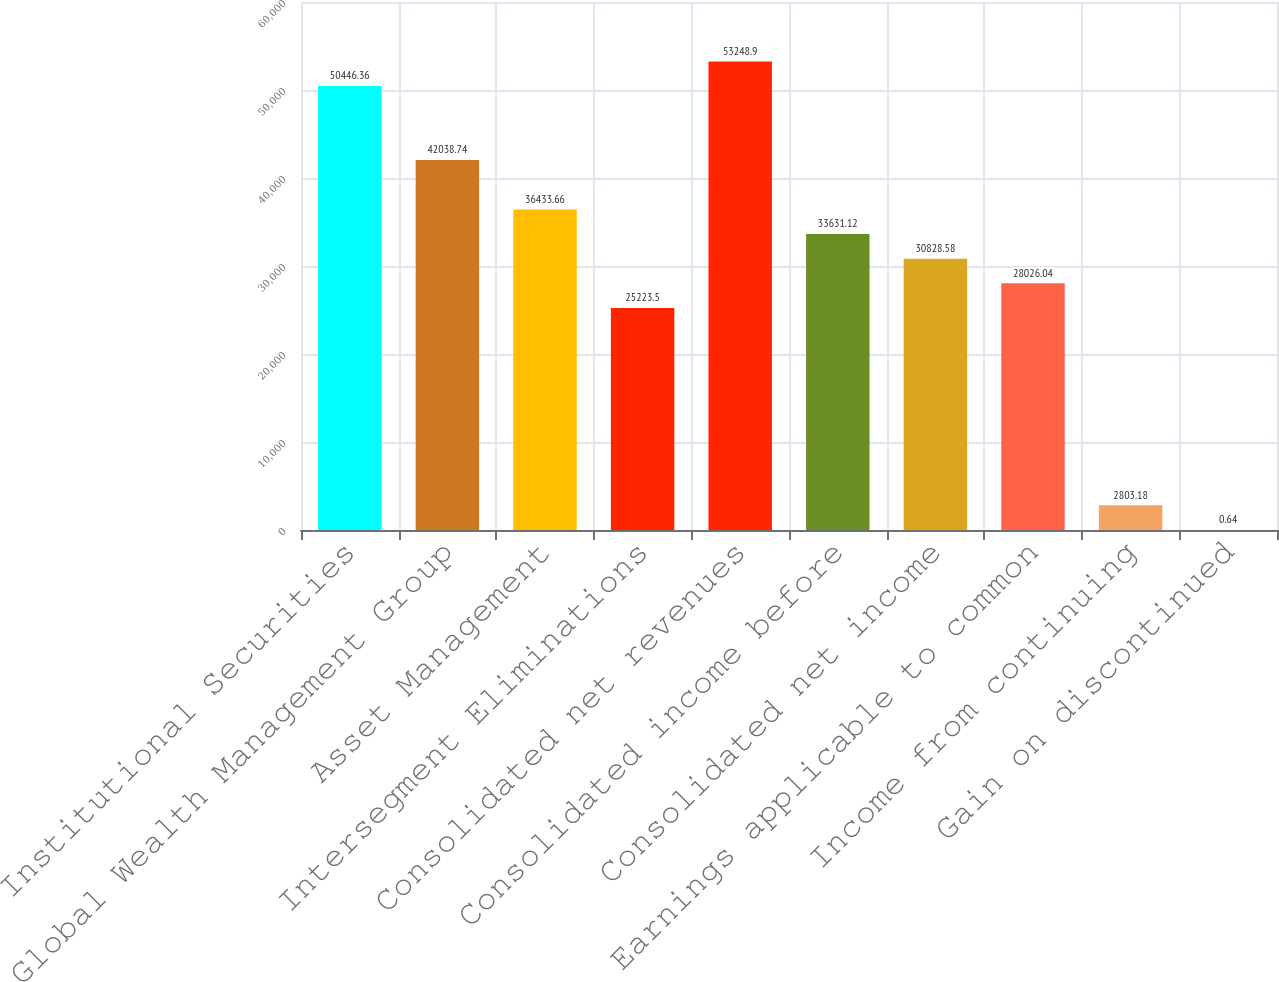Convert chart to OTSL. <chart><loc_0><loc_0><loc_500><loc_500><bar_chart><fcel>Institutional Securities<fcel>Global Wealth Management Group<fcel>Asset Management<fcel>Intersegment Eliminations<fcel>Consolidated net revenues<fcel>Consolidated income before<fcel>Consolidated net income<fcel>Earnings applicable to common<fcel>Income from continuing<fcel>Gain on discontinued<nl><fcel>50446.4<fcel>42038.7<fcel>36433.7<fcel>25223.5<fcel>53248.9<fcel>33631.1<fcel>30828.6<fcel>28026<fcel>2803.18<fcel>0.64<nl></chart> 